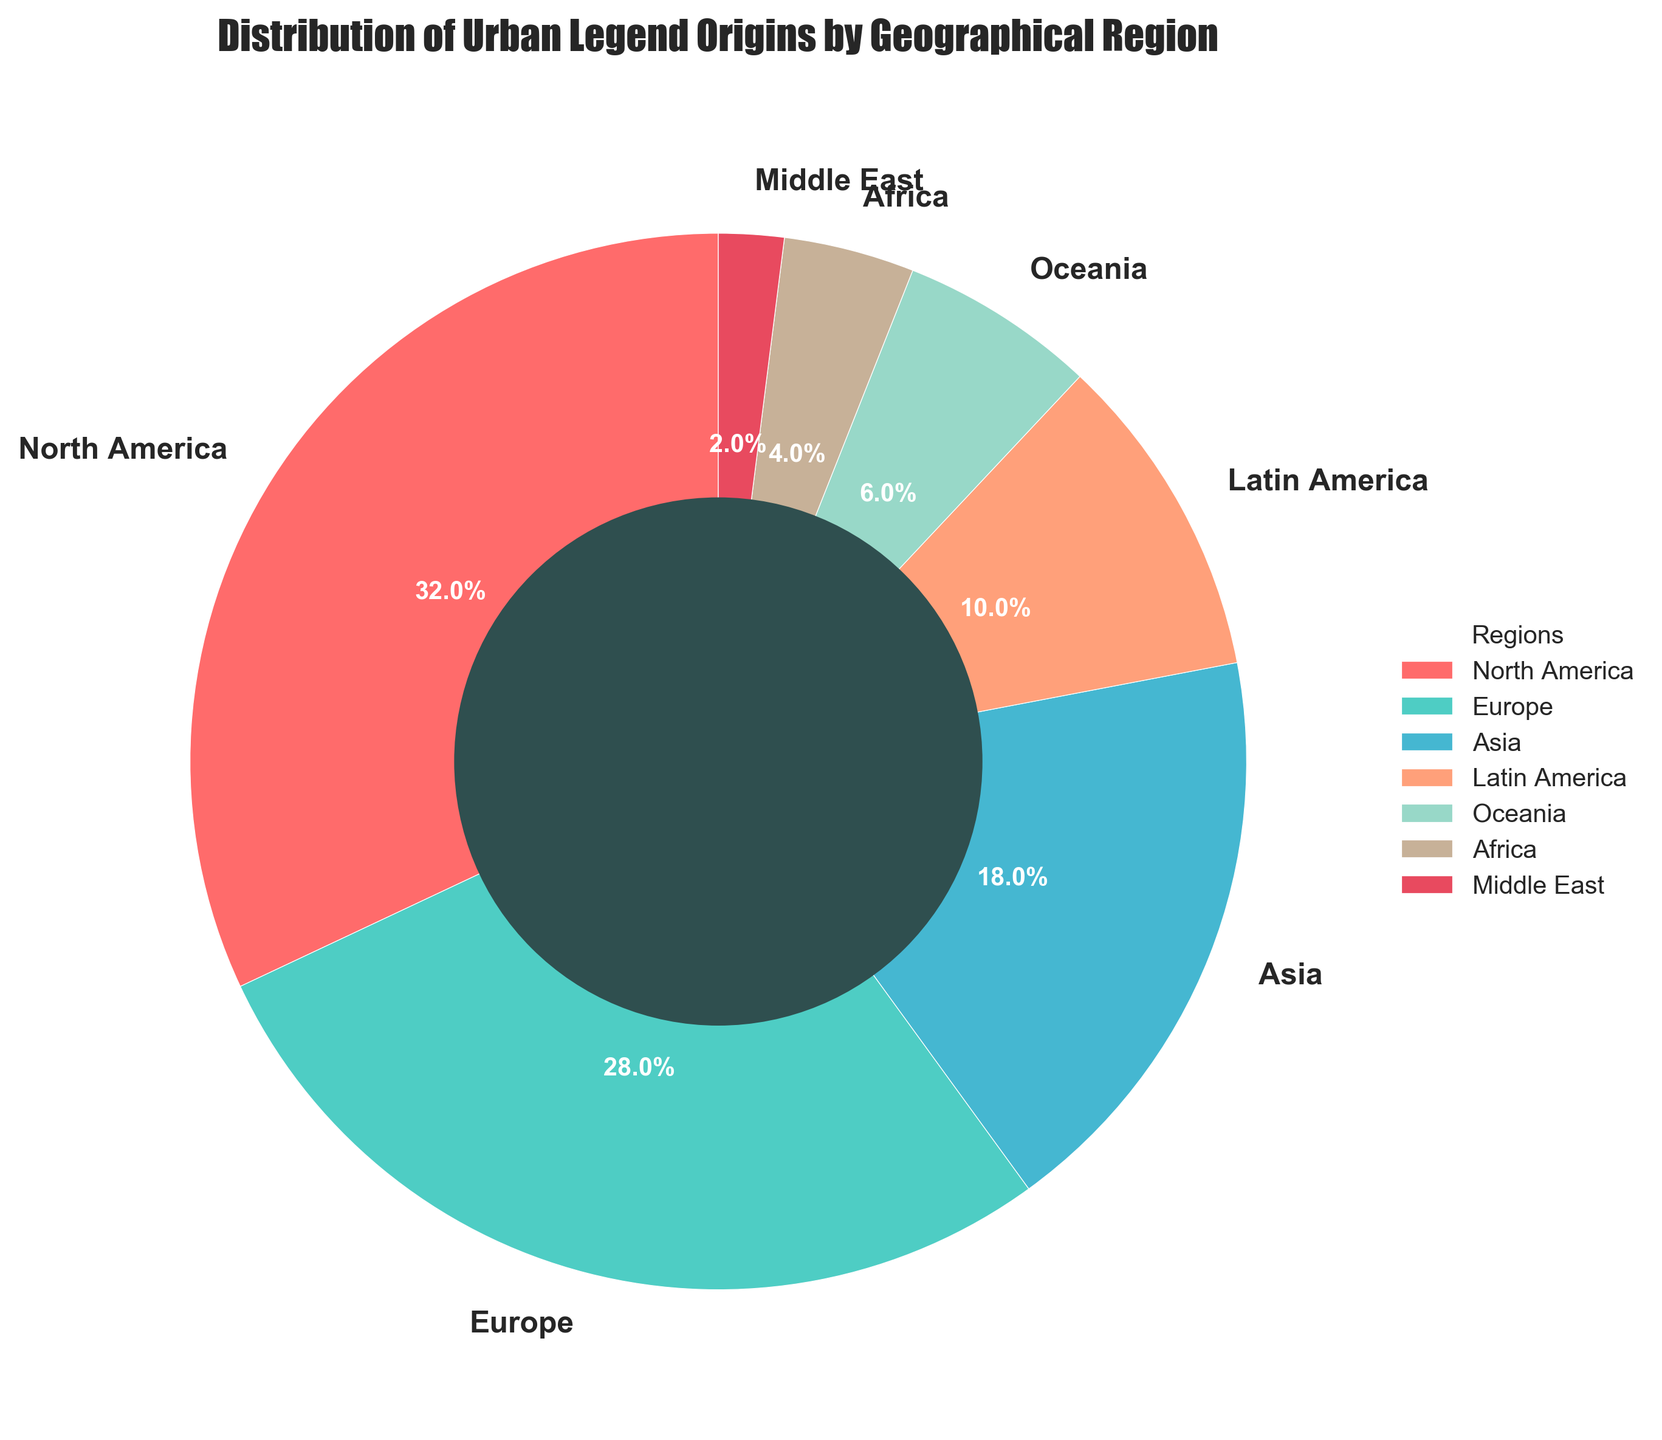Which region has the highest percentage of urban legend origins? The region with the largest segment in the pie chart is North America.
Answer: North America What is the combined percentage of urban legend origins from Europe and Asia? Europe has 28% and Asia has 18%. Summing these percentages: 28% + 18% = 46%.
Answer: 46% How many regions have a percentage lower than 10%? The regions with percentages below 10% are Latin America, Oceania, Africa, and the Middle East, totaling four regions.
Answer: 4 Which region has the smallest contribution to urban legend origins? The region with the smallest segment in the pie chart is the Middle East.
Answer: Middle East Is the percentage of urban legend origins from Africa greater than that from the Middle East? Africa accounts for 4% while the Middle East accounts for 2%. Since 4% is greater than 2%, yes, Africa's percentage is greater.
Answer: Yes Compare the percentages of urban legend origins from Latin America and Oceania. Which one is larger and by how much? Latin America has 10%, and Oceania has 6%. The difference between them is 10% - 6% = 4%.
Answer: Latin America by 4% What is the average percentage of urban legend origins for Africa, Oceania, and the Middle East? Summing the percentages for Africa (4%), Oceania (6%), and the Middle East (2%): 4% + 6% + 2% = 12%. The average is 12% / 3 = 4%.
Answer: 4% If you combine the percentages for North America, Europe, and Asia, what fraction of the total do they represent? The combined percentages are: 32% (North America) + 28% (Europe) + 18% (Asia) = 78%. This is 78% of the total 100%.
Answer: 78% What percentage of urban legend origins does Oceania have in relation to Europe? The percentage for Oceania is 6%, and for Europe, it is 28%. The ratio is 6% / 28% ≈ 0.214 or 21.4%.
Answer: 21.4% 